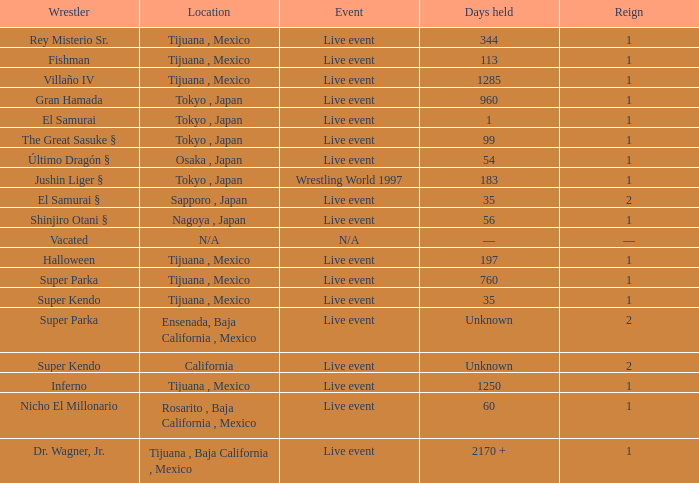Can you give me this table as a dict? {'header': ['Wrestler', 'Location', 'Event', 'Days held', 'Reign'], 'rows': [['Rey Misterio Sr.', 'Tijuana , Mexico', 'Live event', '344', '1'], ['Fishman', 'Tijuana , Mexico', 'Live event', '113', '1'], ['Villaño IV', 'Tijuana , Mexico', 'Live event', '1285', '1'], ['Gran Hamada', 'Tokyo , Japan', 'Live event', '960', '1'], ['El Samurai', 'Tokyo , Japan', 'Live event', '1', '1'], ['The Great Sasuke §', 'Tokyo , Japan', 'Live event', '99', '1'], ['Último Dragón §', 'Osaka , Japan', 'Live event', '54', '1'], ['Jushin Liger §', 'Tokyo , Japan', 'Wrestling World 1997', '183', '1'], ['El Samurai §', 'Sapporo , Japan', 'Live event', '35', '2'], ['Shinjiro Otani §', 'Nagoya , Japan', 'Live event', '56', '1'], ['Vacated', 'N/A', 'N/A', '—', '—'], ['Halloween', 'Tijuana , Mexico', 'Live event', '197', '1'], ['Super Parka', 'Tijuana , Mexico', 'Live event', '760', '1'], ['Super Kendo', 'Tijuana , Mexico', 'Live event', '35', '1'], ['Super Parka', 'Ensenada, Baja California , Mexico', 'Live event', 'Unknown', '2'], ['Super Kendo', 'California', 'Live event', 'Unknown', '2'], ['Inferno', 'Tijuana , Mexico', 'Live event', '1250', '1'], ['Nicho El Millonario', 'Rosarito , Baja California , Mexico', 'Live event', '60', '1'], ['Dr. Wagner, Jr.', 'Tijuana , Baja California , Mexico', 'Live event', '2170 +', '1']]} What type of event had the wrestler with a reign of 2 and held the title for 35 days? Live event. 